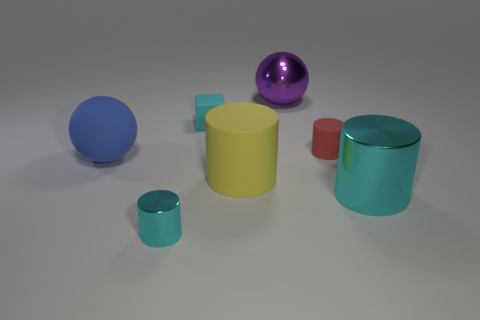Add 3 big blue rubber things. How many objects exist? 10 Subtract 2 cylinders. How many cylinders are left? 2 Add 2 purple things. How many purple things are left? 3 Add 2 green shiny things. How many green shiny things exist? 2 Subtract all yellow cylinders. How many cylinders are left? 3 Subtract all tiny red cylinders. How many cylinders are left? 3 Subtract 0 purple cubes. How many objects are left? 7 Subtract all cylinders. How many objects are left? 3 Subtract all brown blocks. Subtract all purple balls. How many blocks are left? 1 Subtract all gray spheres. How many red cylinders are left? 1 